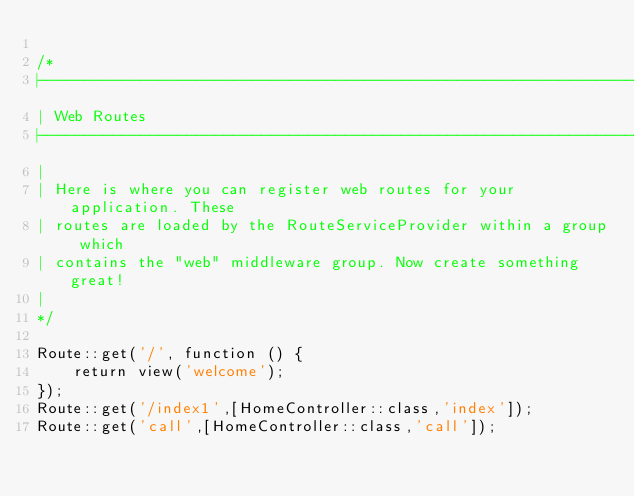Convert code to text. <code><loc_0><loc_0><loc_500><loc_500><_PHP_>
/*
|--------------------------------------------------------------------------
| Web Routes
|--------------------------------------------------------------------------
|
| Here is where you can register web routes for your application. These
| routes are loaded by the RouteServiceProvider within a group which
| contains the "web" middleware group. Now create something great!
|
*/

Route::get('/', function () {
    return view('welcome');
});
Route::get('/index1',[HomeController::class,'index']);
Route::get('call',[HomeController::class,'call']);</code> 